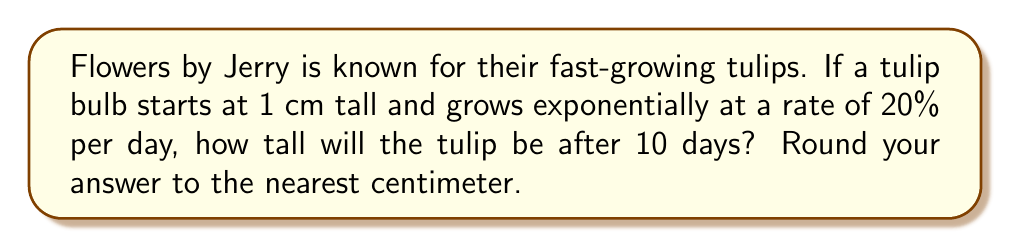Can you answer this question? Let's approach this step-by-step:

1) The exponential growth function is given by:
   $$ h(t) = h_0 \cdot (1 + r)^t $$
   where:
   $h(t)$ is the height at time $t$
   $h_0$ is the initial height
   $r$ is the growth rate
   $t$ is the time

2) We know:
   $h_0 = 1$ cm (initial height)
   $r = 0.20$ (20% growth rate)
   $t = 10$ days

3) Let's substitute these values into our equation:
   $$ h(10) = 1 \cdot (1 + 0.20)^{10} $$

4) Simplify inside the parentheses:
   $$ h(10) = 1 \cdot (1.20)^{10} $$

5) Calculate the exponent:
   $$ h(10) = 1 \cdot 6.1917 $$

6) Multiply:
   $$ h(10) = 6.1917 $$

7) Round to the nearest centimeter:
   $$ h(10) \approx 6 \text{ cm} $$

Therefore, after 10 days, the tulip will be approximately 6 cm tall.
Answer: 6 cm 